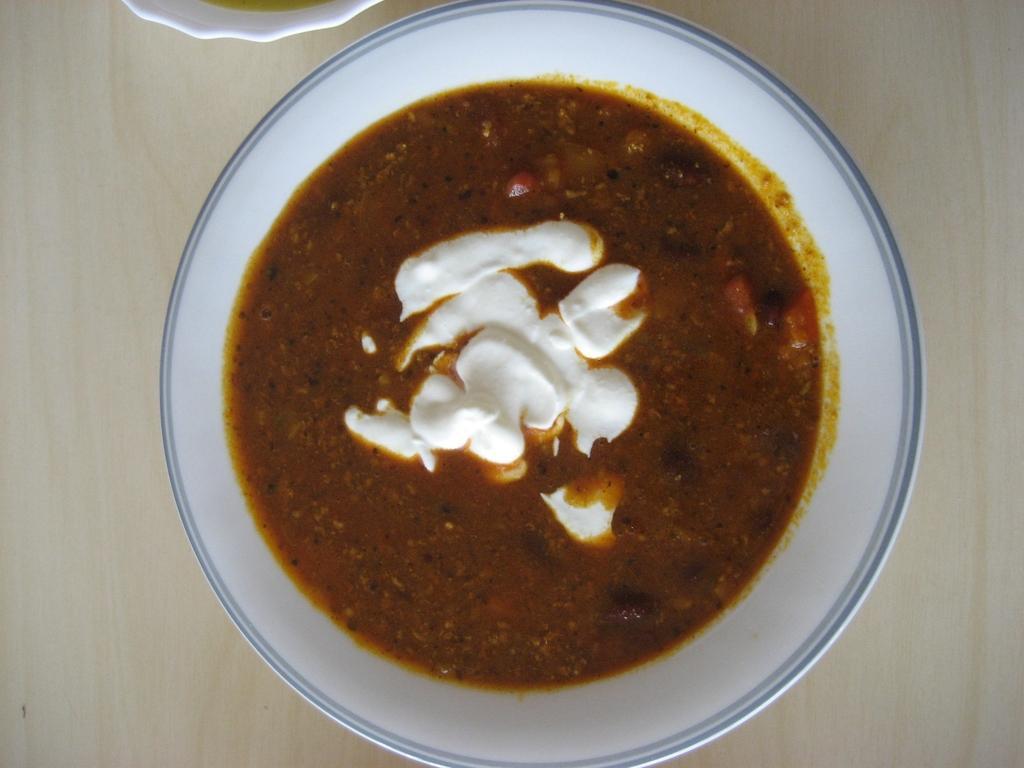Could you give a brief overview of what you see in this image? In this picture I can see the bowl and cup which is kept on the table. In that bowl I can see the food item. 